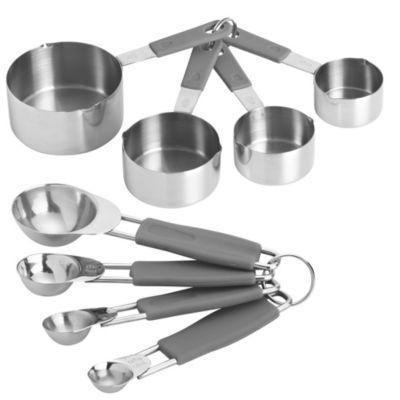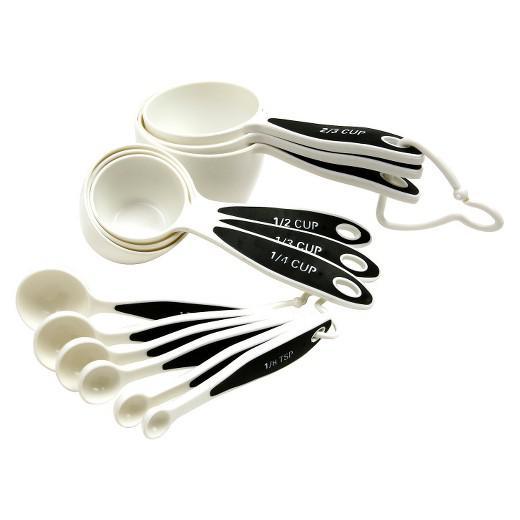The first image is the image on the left, the second image is the image on the right. Considering the images on both sides, is "One the set of measuring spoons is white with black handles." valid? Answer yes or no. Yes. 